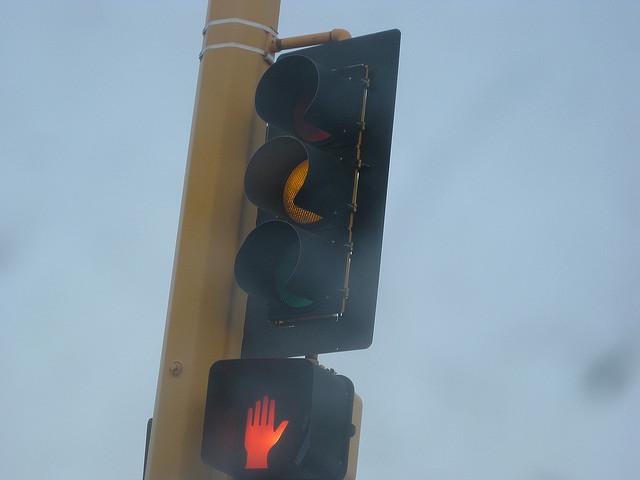Are there clouds visible?
Quick response, please. Yes. What does the hand light represent?
Concise answer only. Stop. What light is the stoplight on?
Answer briefly. Yellow. 